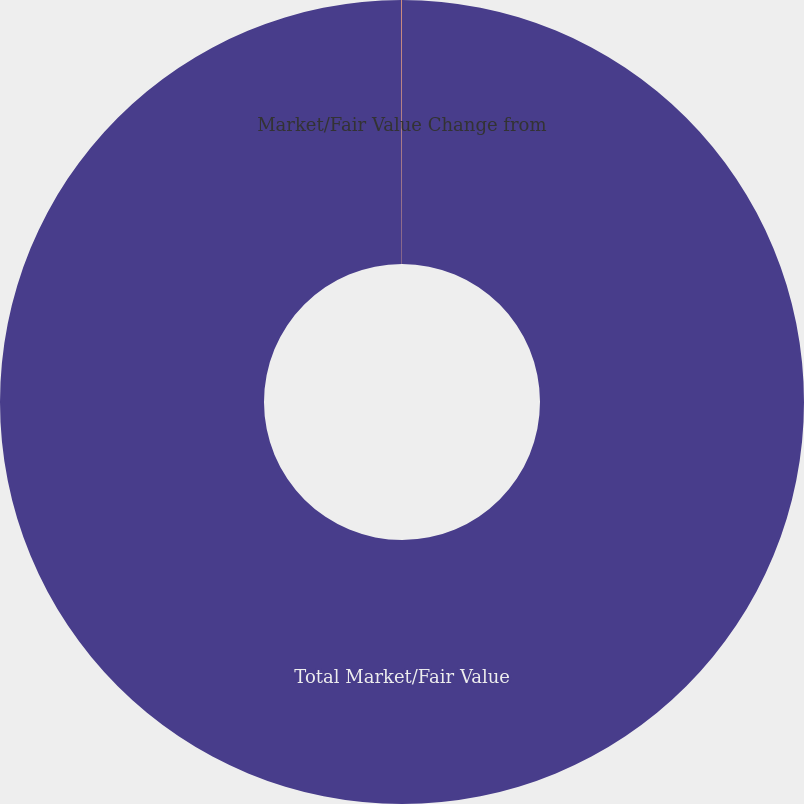Convert chart. <chart><loc_0><loc_0><loc_500><loc_500><pie_chart><fcel>Total Market/Fair Value<fcel>Market/Fair Value Change from<nl><fcel>99.98%<fcel>0.02%<nl></chart> 